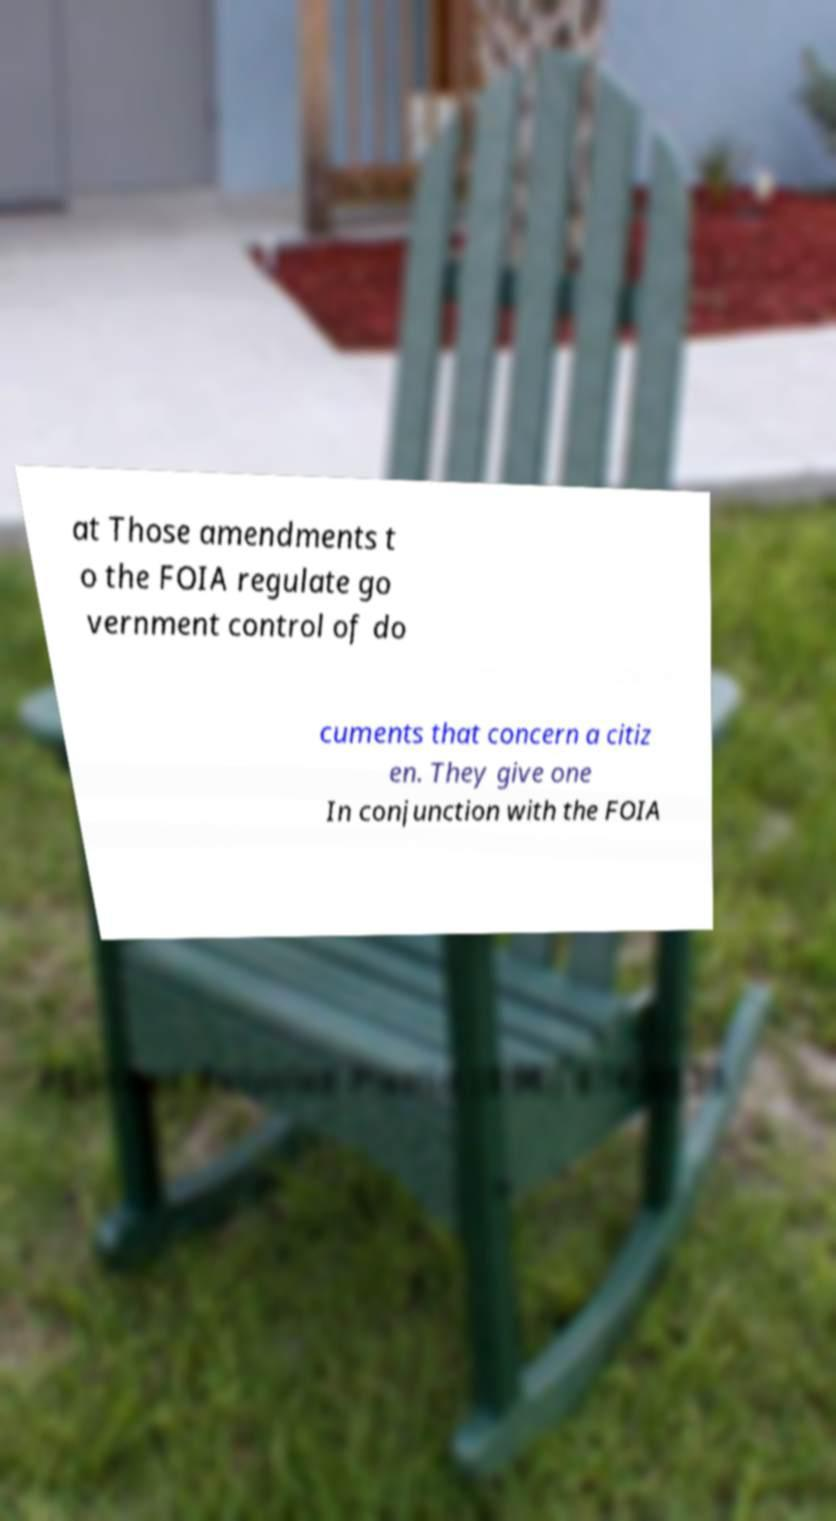Please read and relay the text visible in this image. What does it say? at Those amendments t o the FOIA regulate go vernment control of do cuments that concern a citiz en. They give one In conjunction with the FOIA 